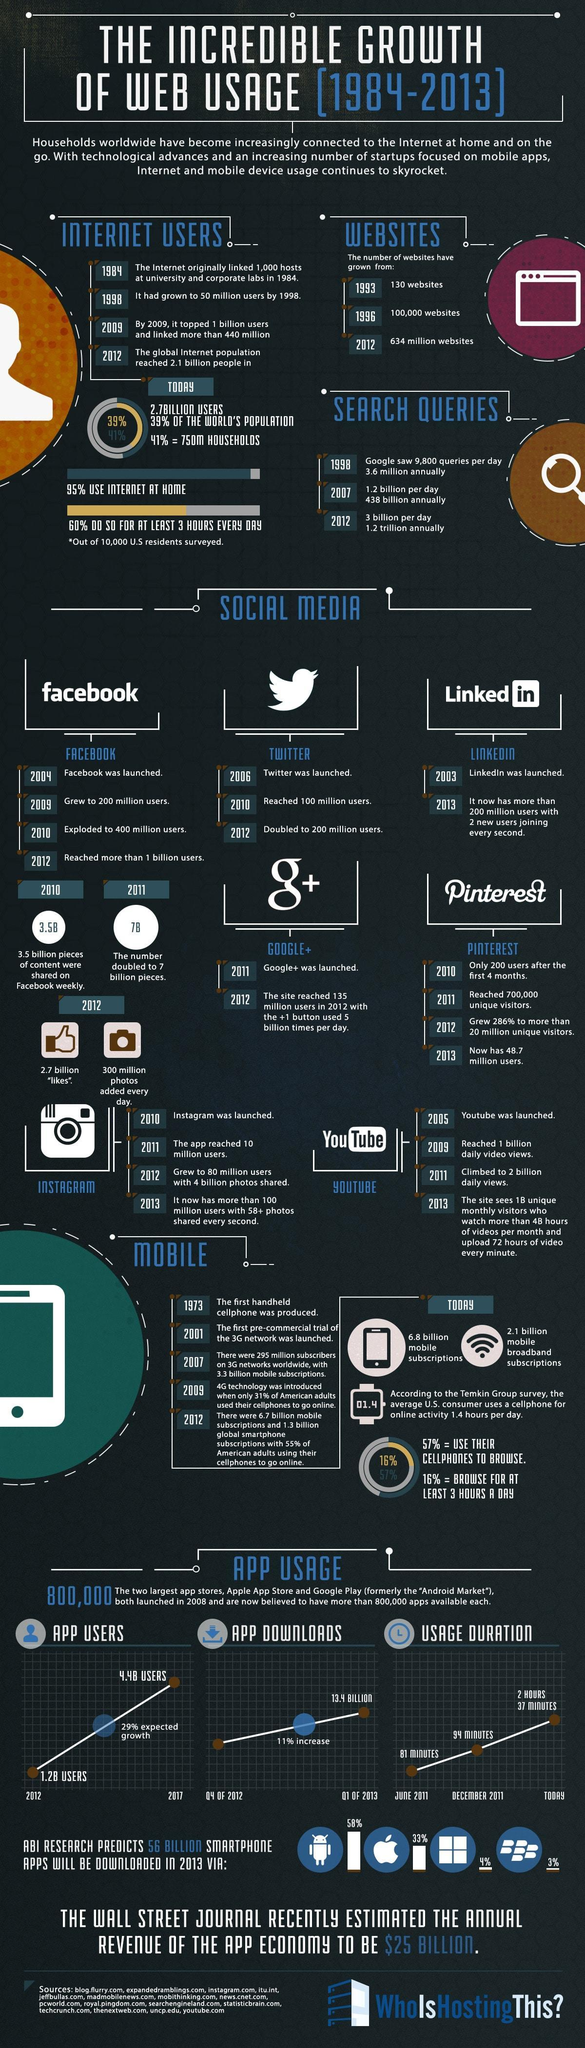What is the predicted percentage of app downloads in 2013 via android phones?
Answer the question with a short phrase. 58% Which social network was launched earlier - Facebook, LinkedIn or Twitter? LinkedIn Which social network reached 100 million users in 2010? Twitter Which social media platform had only 200 users after the first 4 months in 2010? Pinterest In which year was the search queries per day on Google near to 10,000? 1998 Which site had the +1 button used 5billion times/day by 2012? Google+ By 2013 which site had 72 hours of video upload every minute? YouTube Which social network exploded to 400 million users in 2010? Facebook Which app reached 10 million users in 2011? Instagram 33% of the smartphone apps downloaded in 2013 will be via which brand of phones - Android, Windows or Apple? Apple 